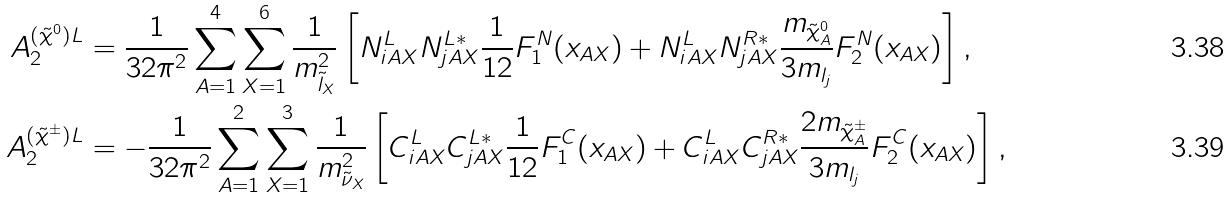Convert formula to latex. <formula><loc_0><loc_0><loc_500><loc_500>A _ { 2 } ^ { ( \tilde { \chi } ^ { 0 } ) L } & = \frac { 1 } { 3 2 \pi ^ { 2 } } \sum _ { A = 1 } ^ { 4 } \sum _ { X = 1 } ^ { 6 } \frac { 1 } { m _ { \tilde { l } _ { X } } ^ { 2 } } \left [ N _ { i A X } ^ { L } N _ { j A X } ^ { L * } \frac { 1 } { 1 2 } F _ { 1 } ^ { N } ( x _ { A X } ) + N _ { i A X } ^ { L } N _ { j A X } ^ { R * } \frac { m _ { \tilde { \chi } ^ { 0 } _ { A } } } { 3 m _ { l _ { j } } } F _ { 2 } ^ { N } ( x _ { A X } ) \right ] , \\ A _ { 2 } ^ { ( \tilde { \chi } ^ { \pm } ) L } & = - \frac { 1 } { 3 2 \pi ^ { 2 } } \sum _ { A = 1 } ^ { 2 } \sum _ { X = 1 } ^ { 3 } \frac { 1 } { m _ { \tilde { \nu } _ { X } } ^ { 2 } } \left [ C _ { i A X } ^ { L } C _ { j A X } ^ { L * } \frac { 1 } { 1 2 } F _ { 1 } ^ { C } ( x _ { A X } ) + C _ { i A X } ^ { L } C _ { j A X } ^ { R * } \frac { 2 m _ { \tilde { \chi } ^ { \pm } _ { A } } } { 3 m _ { l _ { j } } } F _ { 2 } ^ { C } ( x _ { A X } ) \right ] ,</formula> 